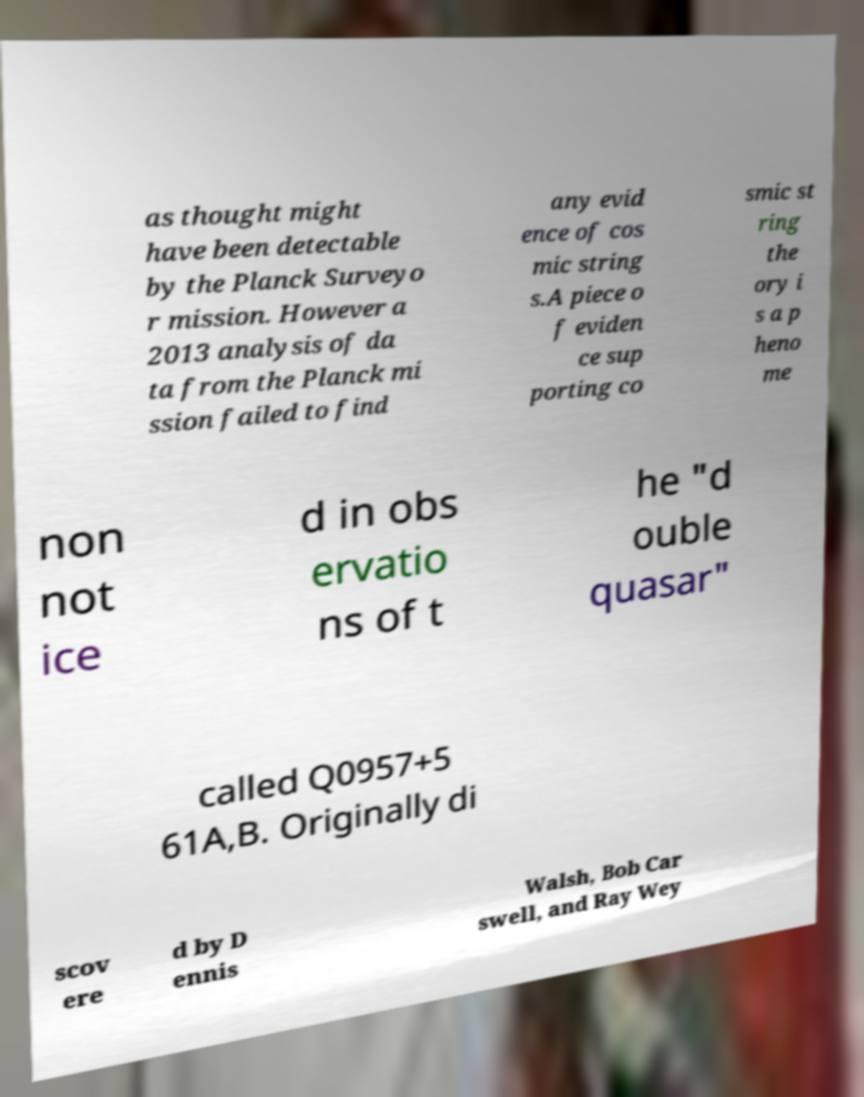Please read and relay the text visible in this image. What does it say? as thought might have been detectable by the Planck Surveyo r mission. However a 2013 analysis of da ta from the Planck mi ssion failed to find any evid ence of cos mic string s.A piece o f eviden ce sup porting co smic st ring the ory i s a p heno me non not ice d in obs ervatio ns of t he "d ouble quasar" called Q0957+5 61A,B. Originally di scov ere d by D ennis Walsh, Bob Car swell, and Ray Wey 